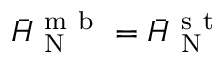Convert formula to latex. <formula><loc_0><loc_0><loc_500><loc_500>\ B a r { H } _ { N } ^ { m b } = \ B a r { H } _ { N } ^ { s t }</formula> 